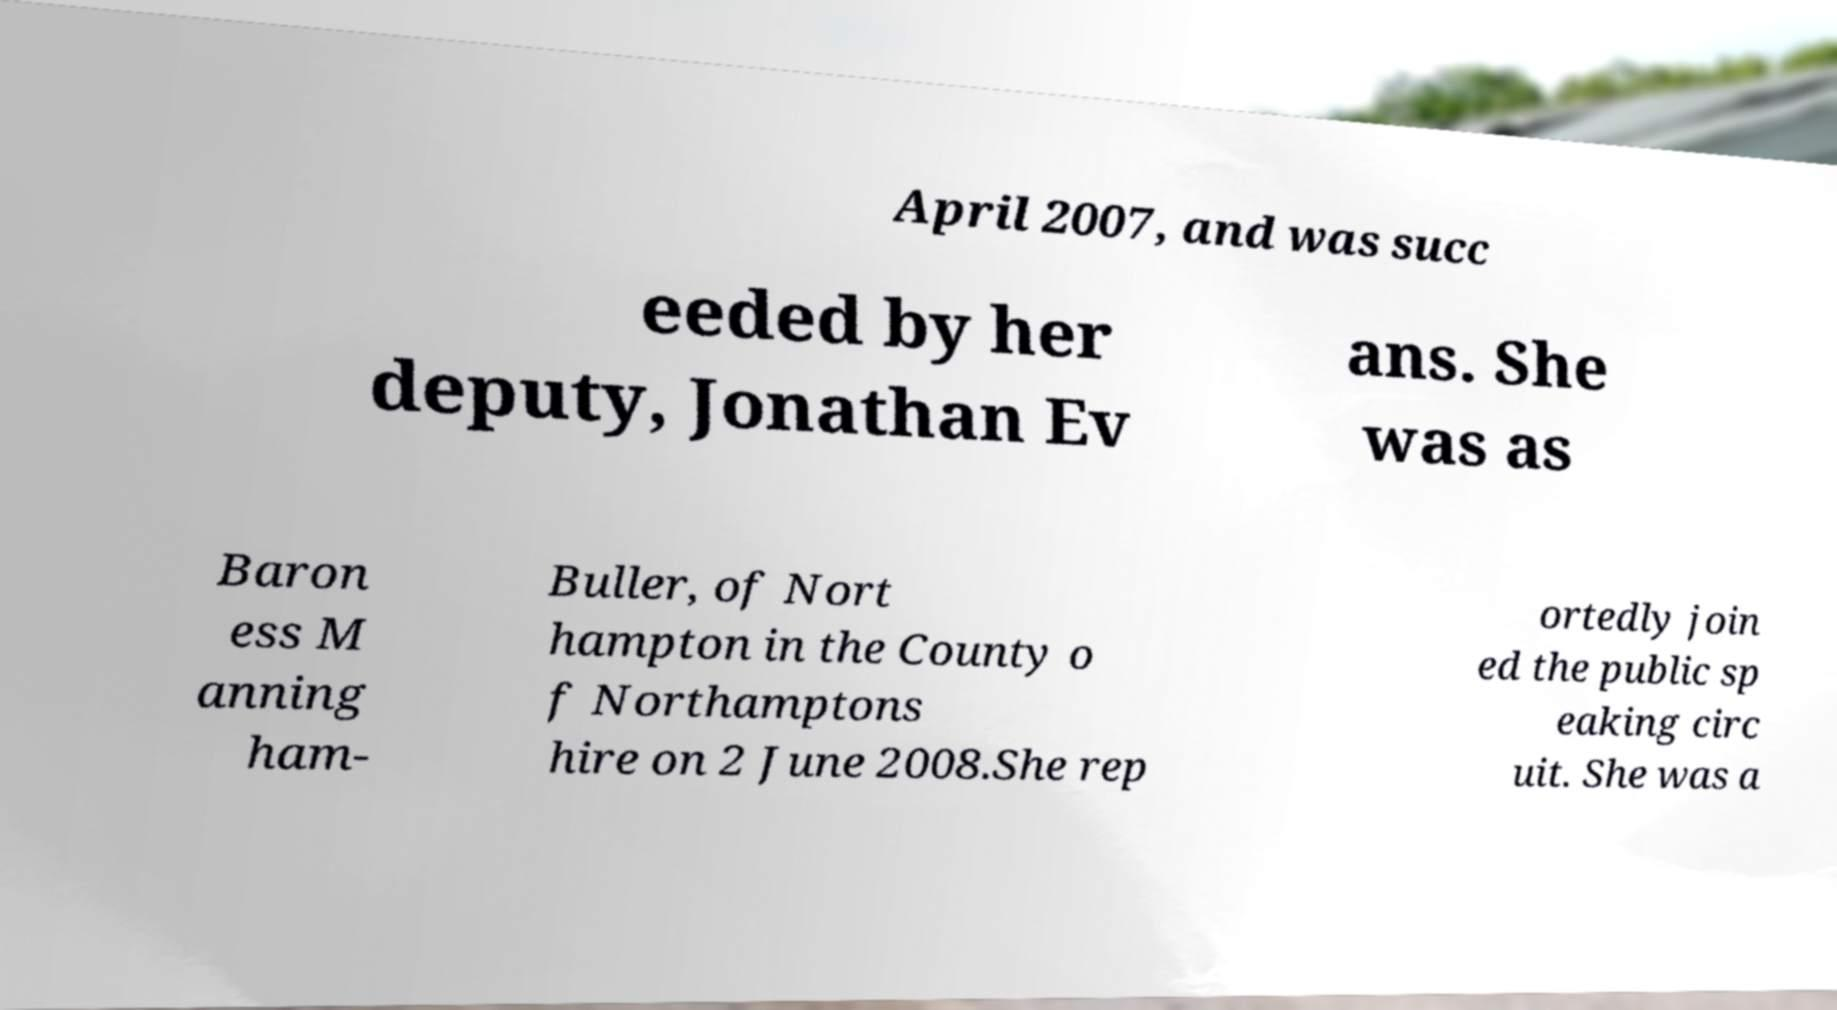Could you extract and type out the text from this image? April 2007, and was succ eeded by her deputy, Jonathan Ev ans. She was as Baron ess M anning ham- Buller, of Nort hampton in the County o f Northamptons hire on 2 June 2008.She rep ortedly join ed the public sp eaking circ uit. She was a 